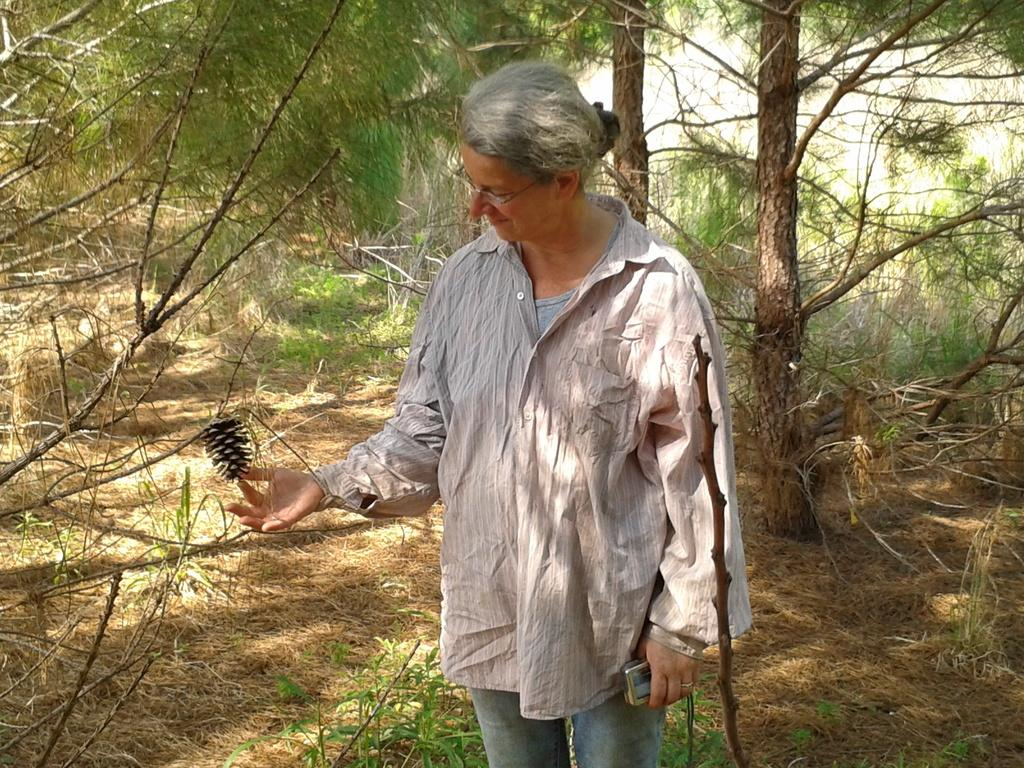Who is present in the image? There is a woman in the image. Where is the woman located? The woman is standing in a forest. What is the woman holding in her hand? The woman is holding dry fruit in her hand. What can be seen in the background of the image? There are trees in the background of the image. What is present on the ground in the image? Dry leaves are present on the ground in the image. Is there a tent set up in the image? No, there is no tent present in the image. Can you see any quicksand in the image? No, there is no quicksand present in the image. 